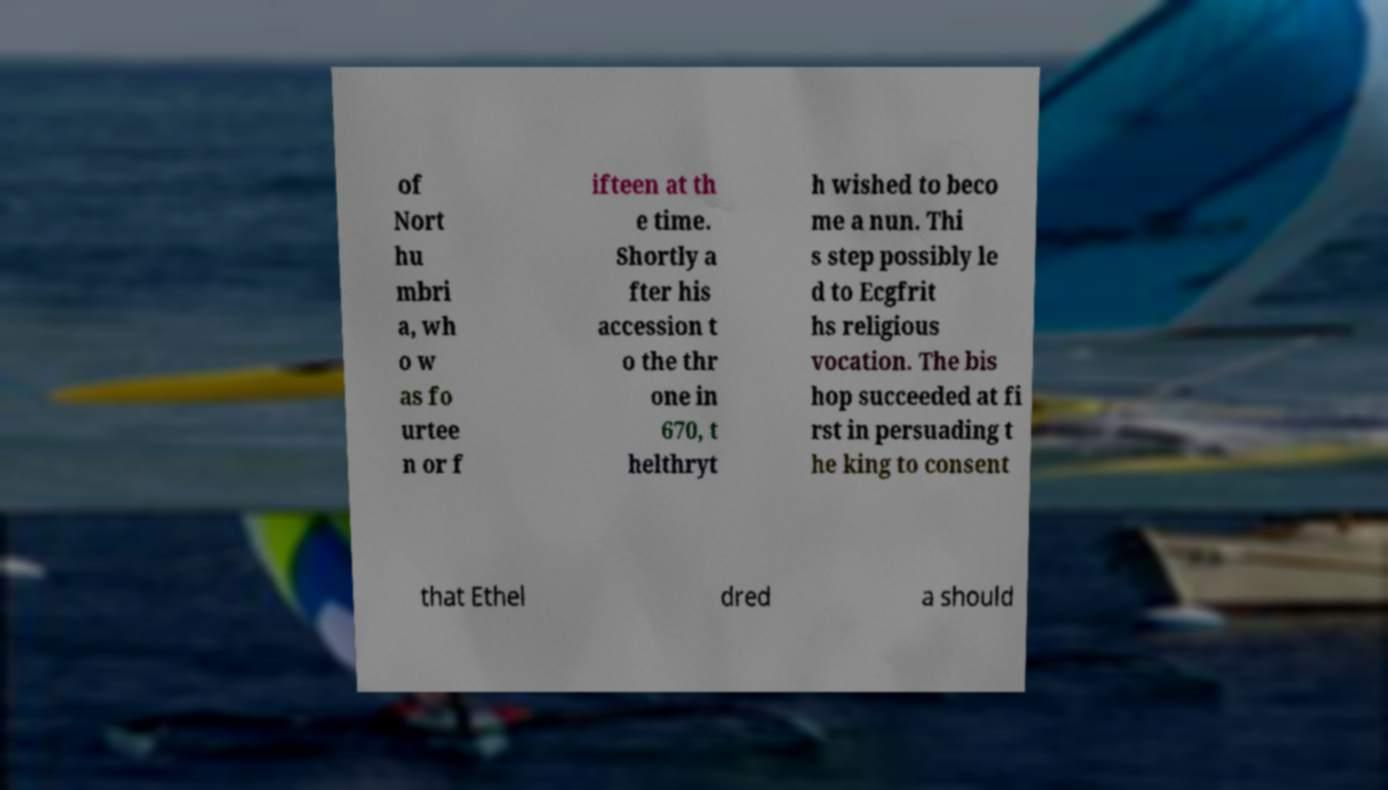Could you extract and type out the text from this image? of Nort hu mbri a, wh o w as fo urtee n or f ifteen at th e time. Shortly a fter his accession t o the thr one in 670, t helthryt h wished to beco me a nun. Thi s step possibly le d to Ecgfrit hs religious vocation. The bis hop succeeded at fi rst in persuading t he king to consent that Ethel dred a should 